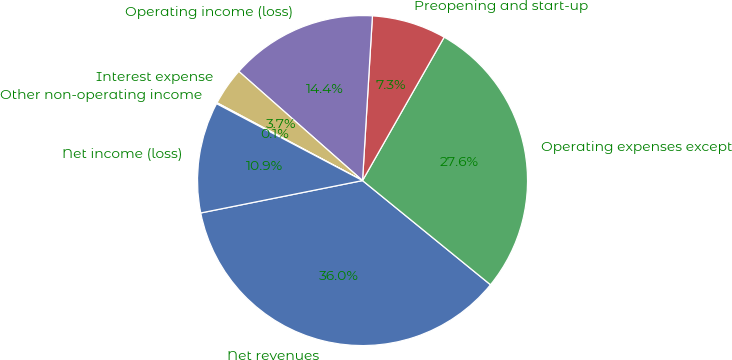<chart> <loc_0><loc_0><loc_500><loc_500><pie_chart><fcel>Net revenues<fcel>Operating expenses except<fcel>Preopening and start-up<fcel>Operating income (loss)<fcel>Interest expense<fcel>Other non-operating income<fcel>Net income (loss)<nl><fcel>35.98%<fcel>27.64%<fcel>7.28%<fcel>14.45%<fcel>3.69%<fcel>0.1%<fcel>10.86%<nl></chart> 